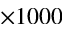Convert formula to latex. <formula><loc_0><loc_0><loc_500><loc_500>\times 1 0 0 0</formula> 